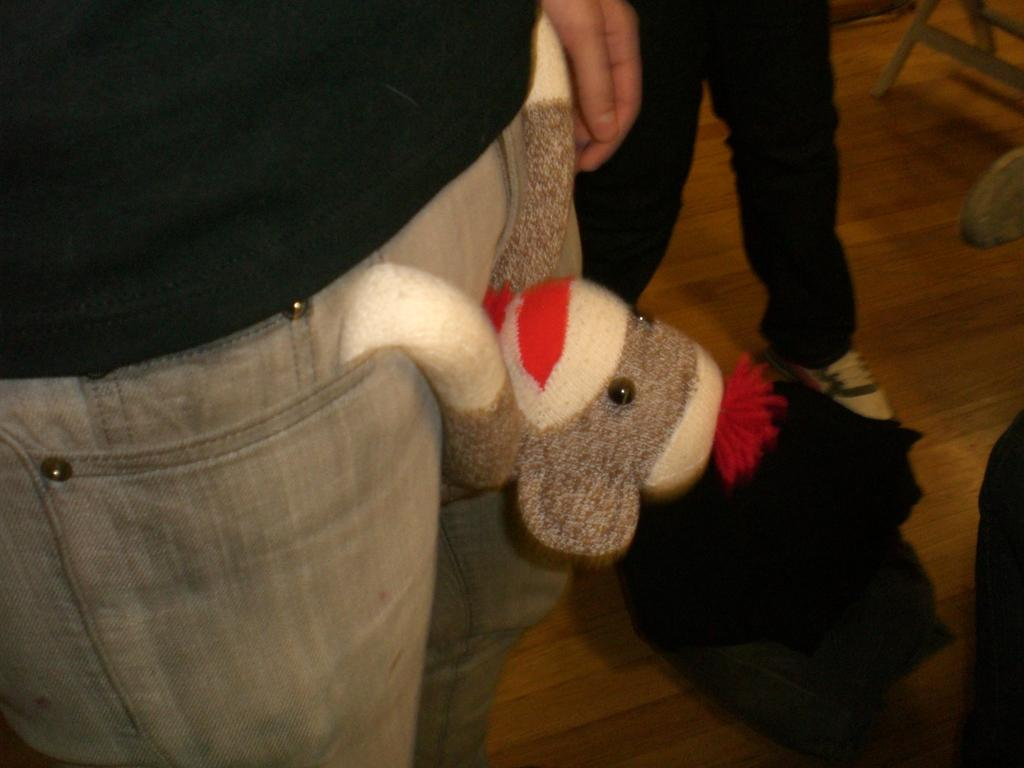What is hanging from the person's pocket in the image? There is a dog hanging from the person's pocket in the image. What else can be seen near the person with the dog? There are legs of another person beside the first person. What is located beside the first person? There is a chair beside the first person. What type of goat can be seen grazing on the star in the image? There is no goat or star present in the image; it only features a dog hanging from a person's pocket and a chair beside the person. 